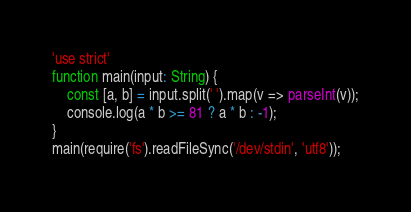<code> <loc_0><loc_0><loc_500><loc_500><_TypeScript_>'use strict'
function main(input: String) {
    const [a, b] = input.split(' ').map(v => parseInt(v));
    console.log(a * b >= 81 ? a * b : -1);
}
main(require('fs').readFileSync('/dev/stdin', 'utf8'));</code> 